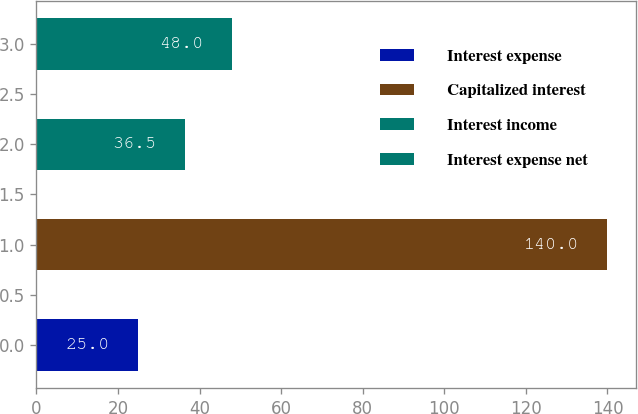Convert chart. <chart><loc_0><loc_0><loc_500><loc_500><bar_chart><fcel>Interest expense<fcel>Capitalized interest<fcel>Interest income<fcel>Interest expense net<nl><fcel>25<fcel>140<fcel>36.5<fcel>48<nl></chart> 